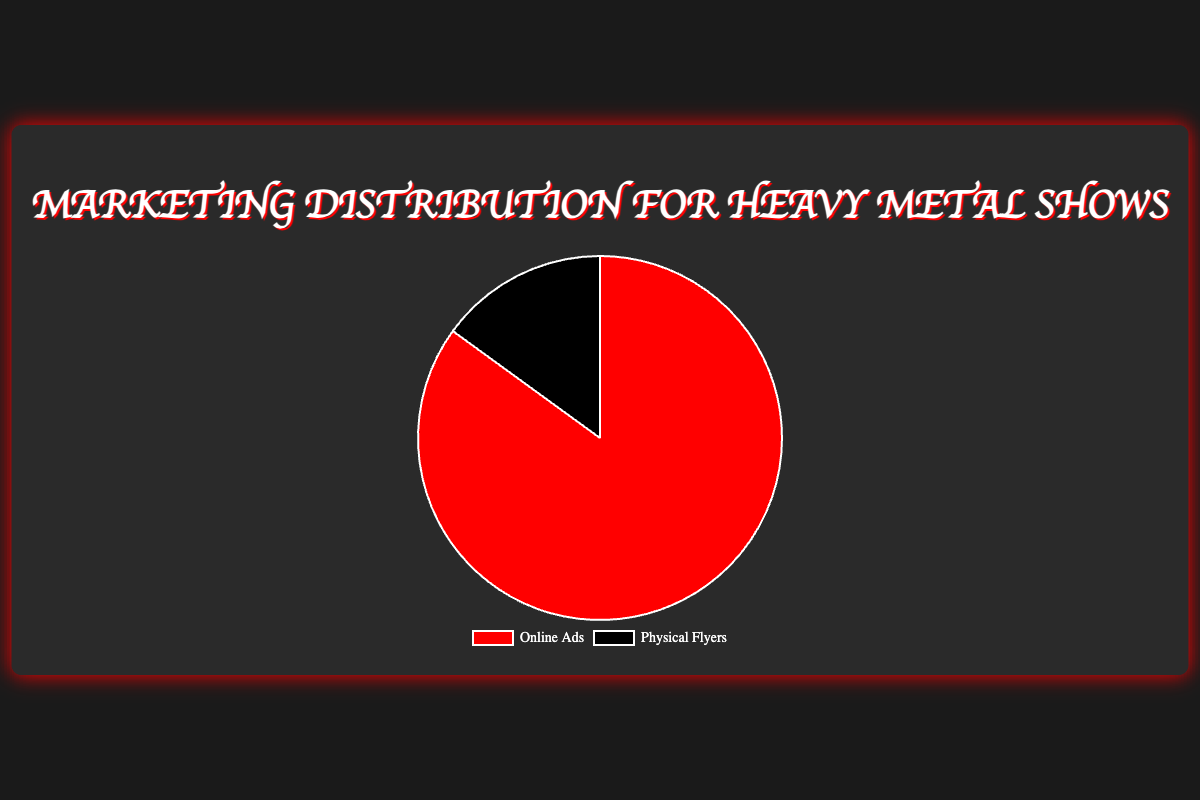What's the most significant portion of marketing efforts? The pie chart shows two categories: Online Ads and Physical Flyers. The visually larger portion is labeled "Online Ads" with 85%, making it the most significant.
Answer: Online Ads By how many percentage points do Online Ads exceed Physical Flyers? Online Ads account for 85%, while Physical Flyers account for 15%. The difference is 85% - 15% = 70%.
Answer: 70% What is the percentage of marketing efforts attributed to Physical Flyers? The chart clearly shows the percentage for Physical Flyers as one of the segments, which is labeled as 15%.
Answer: 15% Are Online Ads more than 5 times as significant as Physical Flyers in the marketing efforts? Online Ads are 85% and Physical Flyers are 15%. Dividing these: 85 / 15 ≈ 5.67, which is more than 5 times.
Answer: Yes What percentage does not belong to Online Ads in the distribution? The total percentage is 100%. Since Online Ads take up 85%, the remaining percentage for Physical Flyers is 100% - 85% = 15%.
Answer: 15% If another segment was added to reflect a different marketing effort that accounted for 5%, what would be the new percentage for Online Ads? Currently, Online Ads are 85%. Adding a new segment of 5% means the total is now 105%. The new percentage for Online Ads would be recalculated as (85 / 105) * 100 ≈ 80.95%.
Answer: ~80.95% Compare the visual attributes of the segments representing Online Ads and Physical Flyers. The segment for Online Ads is larger and colored in red, while the segment for Physical Flyers is smaller and colored in black. The red segment visually takes up more space.
Answer: Online Ads: larger, red; Physical Flyers: smaller, black 